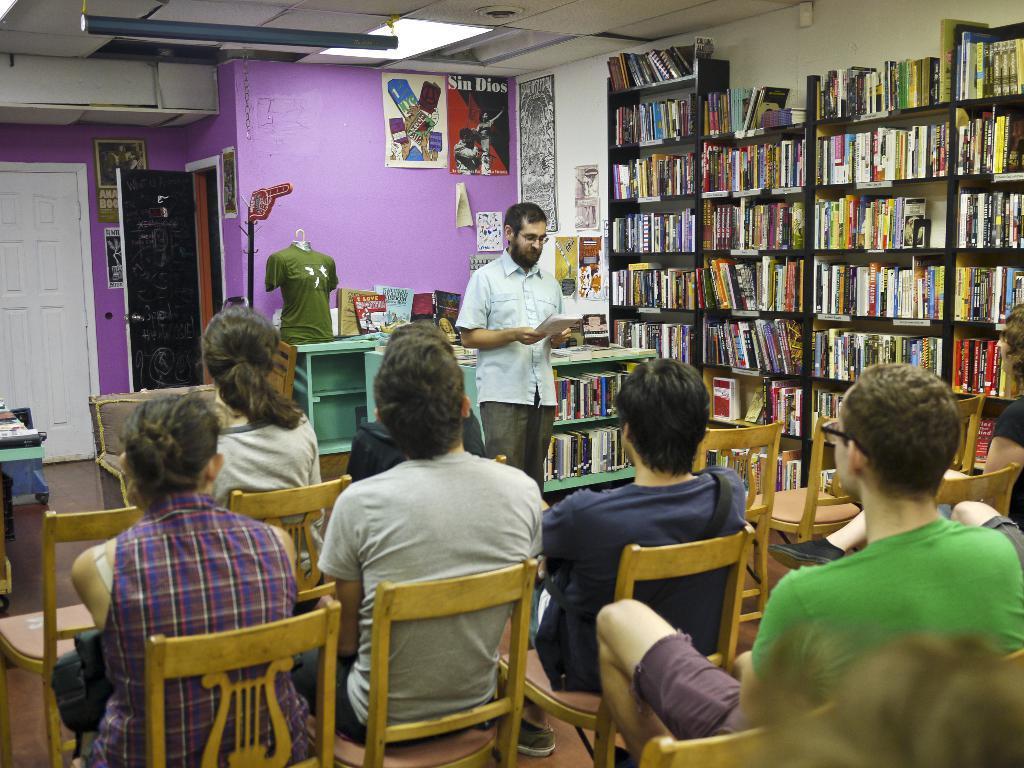Please provide a concise description of this image. In this image, group of people are sat on the chair. At the middle, a person is stand and he hold a book. Right side, we can see big book shelf that are filled with books. In the middle, we can see cupboards , few items are there in it. And the background, we can see wall, door ,some stickers. Left side, there is a white door. The roof white color it is and light. 